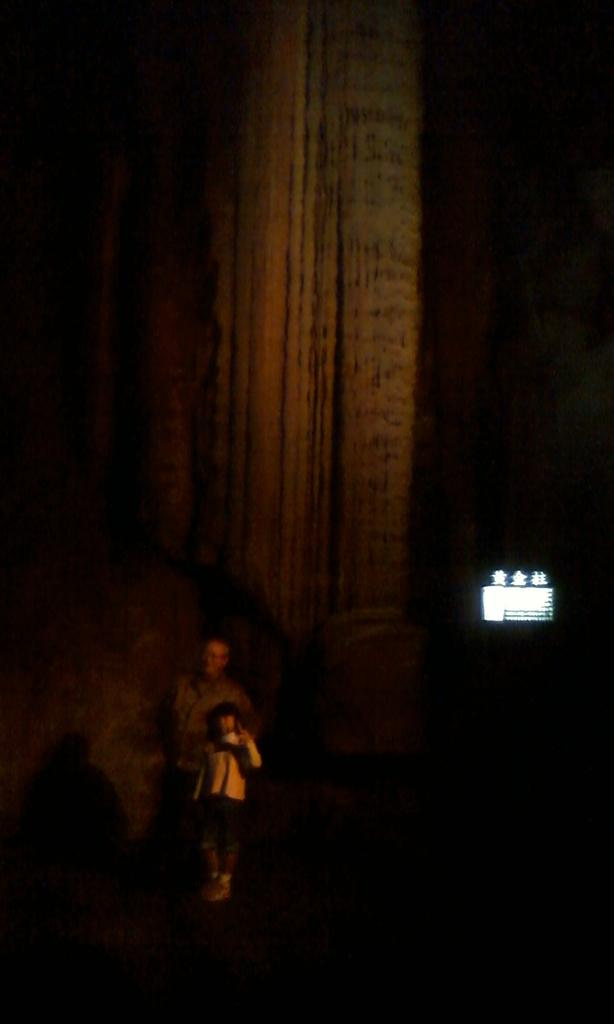Who is present in the image? There is a person and a child in the image. What are the person and the child doing in the image? Both the person and the child are standing. What are they wearing? They are wearing clothes. What can be seen in the background of the image? The corners of the image are dark. What object is visible in the image? There is a screen visible in the image. What type of fuel is being used by the snail in the image? There is no snail present in the image, so it is not possible to determine what type of fuel it might be using. 